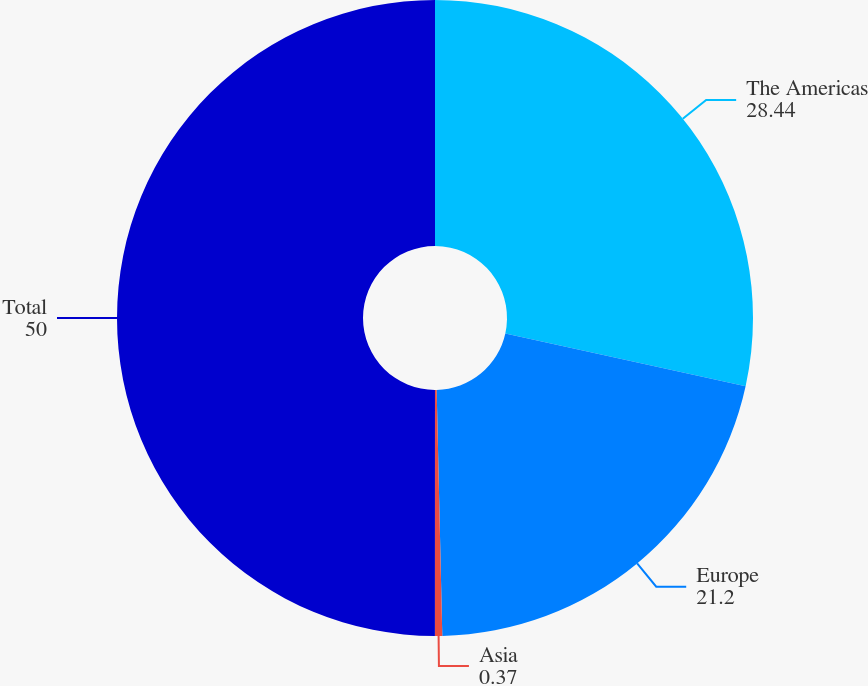<chart> <loc_0><loc_0><loc_500><loc_500><pie_chart><fcel>The Americas<fcel>Europe<fcel>Asia<fcel>Total<nl><fcel>28.44%<fcel>21.2%<fcel>0.37%<fcel>50.0%<nl></chart> 